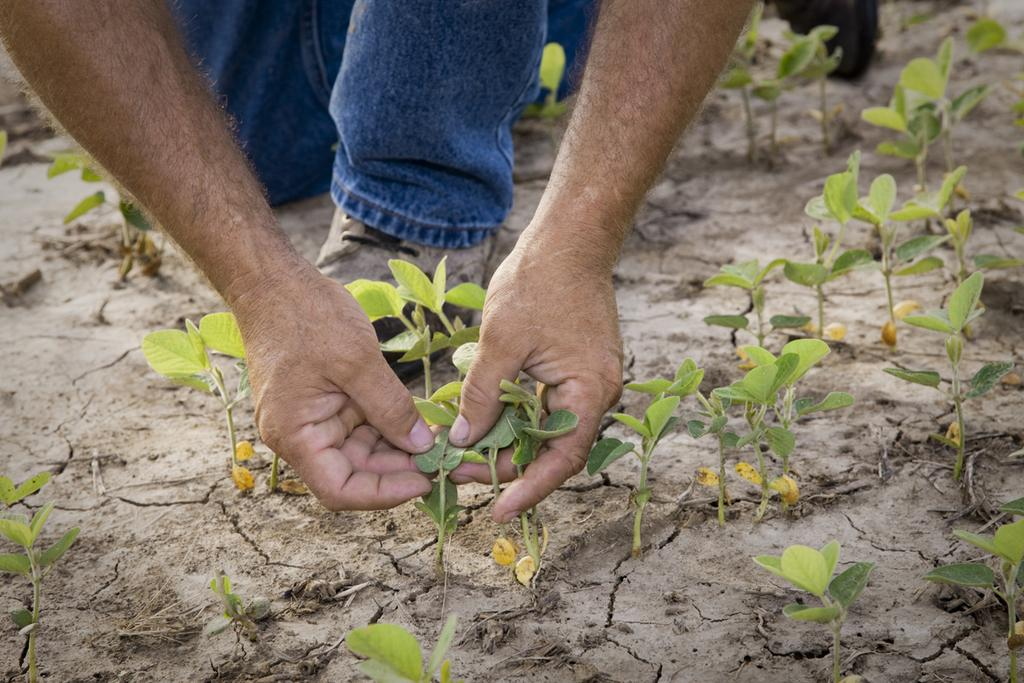What is depicted on the ground in the image? There are planets depicted on the ground in the image. What is the person holding in the image? The person is holding plants in the image. What type of plate is being used to serve the substance in the image? There is no plate or substance present in the image; it features planets depicted on the ground and a person holding plants. How many sisters are visible in the image? There are no sisters present in the image. 